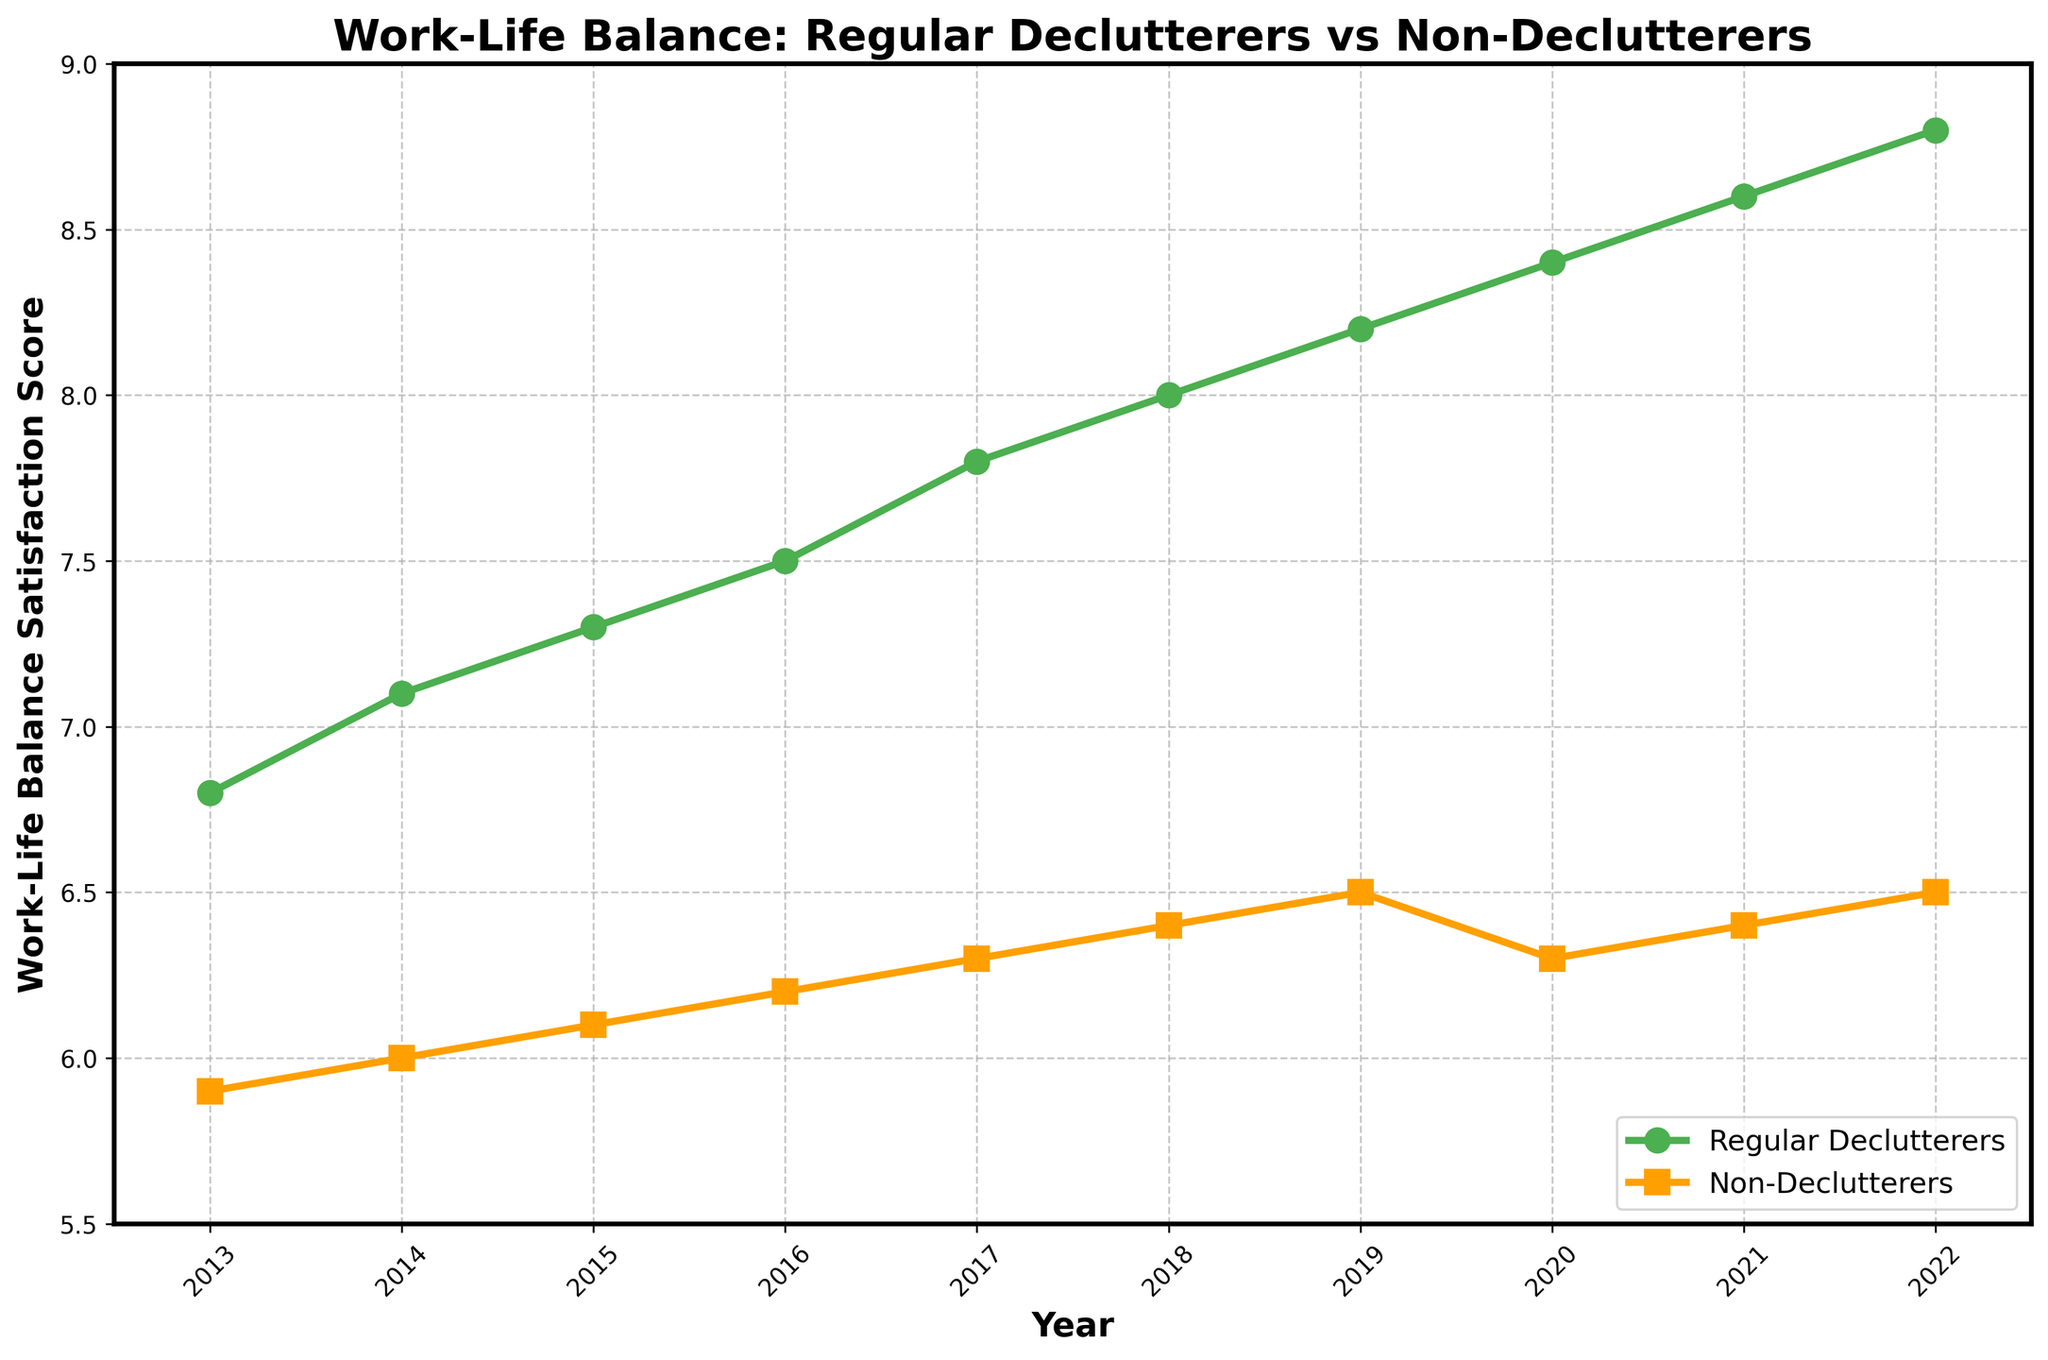when did the satisfaction score of Regular Declutterers reach 8.0? Look at the 'Regular Declutterers' line and find the year where the value is 8.0.
Answer: 2018 What's the difference in the satisfaction scores between Regular Declutterers and Non-Declutterers in 2022? Find the satisfaction scores for Regular Declutterers and Non-Declutterers in 2022 and subtract Non-Declutterers from Regular Declutterers. (8.8 - 6.5 = 2.3)
Answer: 2.3 In which year do Non-Declutterers show a decrease in their satisfaction score? Look at the 'Non-Declutterers' line and find the year where there is a dip in the satisfaction score compared to the previous year. This occurs in 2020.
Answer: 2020 Between which consecutive years did Regular Declutterers experience the highest increase in satisfaction score? Examine the 'Regular Declutterers' line and observe the increments between each pair of consecutive years. The highest increase is from 2021 to 2022 (0.2 increase, from 8.6 to 8.8).
Answer: 2021-2022 Which group had a higher satisfaction score in 2014? Compare the satisfaction scores of Regular Declutterers and Non-Declutterers in 2014. Regular Declutterers had a satisfaction score of 7.1 compared to Non-Declutterers' 6.0.
Answer: Regular Declutterers What is the overall trend shown by Regular Declutterers over the 10-year period? Look at the 'Regular Declutterers' line from 2013 to 2022. The line consistently increases, indicating an upward trend.
Answer: Upward trend How many years did it take for Regular Declutterers to go from a satisfaction score of 7.0 to 8.0? Identify the years when the score was 7.0 (approximately 2014) and 8.0 (2018). Calculate the difference between these years (2018 - 2014 = 4 years).
Answer: 4 years What were the lowest and highest satisfaction scores for Non-Declutterers over the 10-year period? Inspect the 'Non-Declutterers' line for the lowest and highest points. The lowest score is 5.9 in 2013, and the highest is 6.5 in 2022 and previously in 2019.
Answer: 5.9 and 6.5 Which group had a stable satisfaction score around 6.4 in multiple years? Look at the 'Non-Declutterers' line: find the years where it hovers around 6.4 (2018, 2020, 2021).
Answer: Non-Declutterers What is the average satisfaction score of Regular Declutterers for the first 5 years (2013-2017)? Calculate the average of the satisfaction scores for Regular Declutterers from 2013 to 2017. (6.8 + 7.1 + 7.3 + 7.5 + 7.8) / 5 = 7.3
Answer: 7.3 